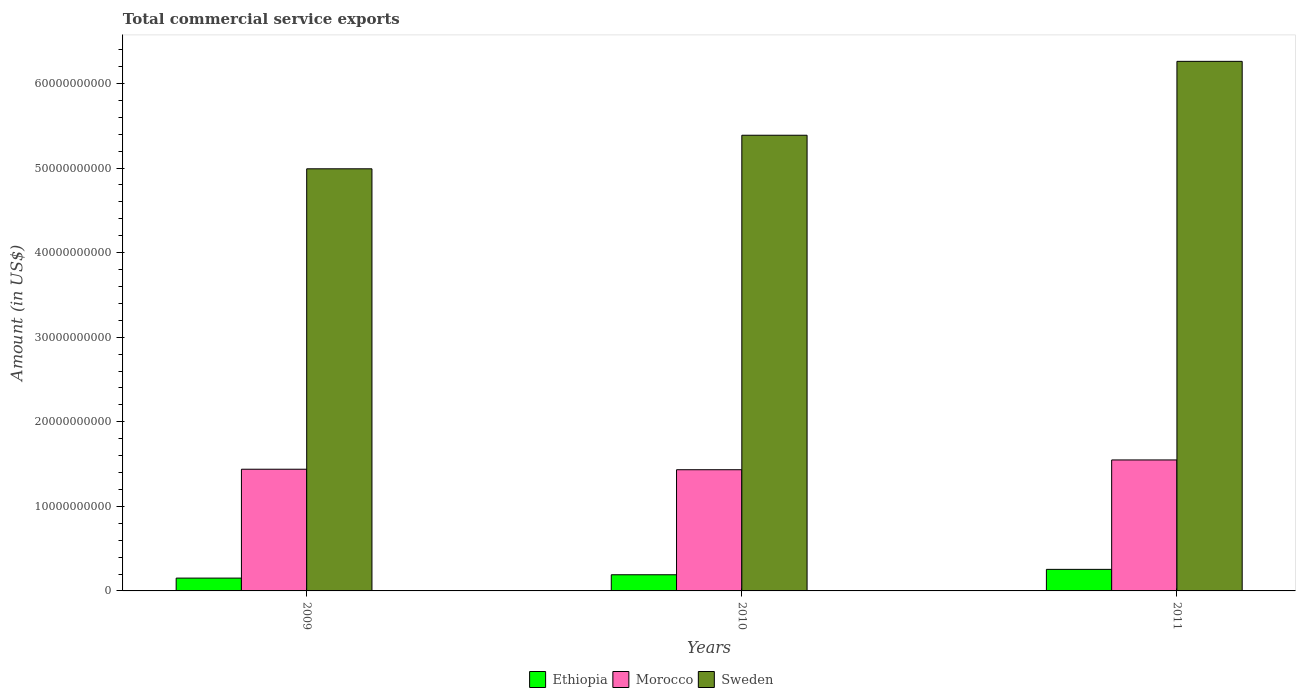How many groups of bars are there?
Ensure brevity in your answer.  3. How many bars are there on the 3rd tick from the right?
Make the answer very short. 3. In how many cases, is the number of bars for a given year not equal to the number of legend labels?
Provide a short and direct response. 0. What is the total commercial service exports in Ethiopia in 2009?
Offer a very short reply. 1.52e+09. Across all years, what is the maximum total commercial service exports in Ethiopia?
Your response must be concise. 2.55e+09. Across all years, what is the minimum total commercial service exports in Morocco?
Your response must be concise. 1.43e+1. What is the total total commercial service exports in Morocco in the graph?
Your answer should be very brief. 4.42e+1. What is the difference between the total commercial service exports in Morocco in 2009 and that in 2010?
Your answer should be very brief. 5.92e+07. What is the difference between the total commercial service exports in Sweden in 2010 and the total commercial service exports in Ethiopia in 2009?
Offer a terse response. 5.24e+1. What is the average total commercial service exports in Sweden per year?
Provide a short and direct response. 5.55e+1. In the year 2010, what is the difference between the total commercial service exports in Sweden and total commercial service exports in Morocco?
Keep it short and to the point. 3.95e+1. What is the ratio of the total commercial service exports in Morocco in 2009 to that in 2011?
Your answer should be very brief. 0.93. Is the total commercial service exports in Ethiopia in 2010 less than that in 2011?
Make the answer very short. Yes. Is the difference between the total commercial service exports in Sweden in 2010 and 2011 greater than the difference between the total commercial service exports in Morocco in 2010 and 2011?
Your response must be concise. No. What is the difference between the highest and the second highest total commercial service exports in Morocco?
Provide a short and direct response. 1.10e+09. What is the difference between the highest and the lowest total commercial service exports in Sweden?
Provide a short and direct response. 1.27e+1. Is the sum of the total commercial service exports in Morocco in 2010 and 2011 greater than the maximum total commercial service exports in Ethiopia across all years?
Provide a short and direct response. Yes. What does the 2nd bar from the left in 2011 represents?
Provide a short and direct response. Morocco. What does the 2nd bar from the right in 2011 represents?
Provide a succinct answer. Morocco. Is it the case that in every year, the sum of the total commercial service exports in Morocco and total commercial service exports in Ethiopia is greater than the total commercial service exports in Sweden?
Keep it short and to the point. No. How many bars are there?
Your answer should be compact. 9. How many years are there in the graph?
Offer a terse response. 3. What is the difference between two consecutive major ticks on the Y-axis?
Your answer should be very brief. 1.00e+1. Are the values on the major ticks of Y-axis written in scientific E-notation?
Your answer should be very brief. No. Where does the legend appear in the graph?
Give a very brief answer. Bottom center. How many legend labels are there?
Your answer should be compact. 3. How are the legend labels stacked?
Your answer should be compact. Horizontal. What is the title of the graph?
Your answer should be compact. Total commercial service exports. What is the label or title of the X-axis?
Make the answer very short. Years. What is the Amount (in US$) of Ethiopia in 2009?
Offer a terse response. 1.52e+09. What is the Amount (in US$) in Morocco in 2009?
Offer a terse response. 1.44e+1. What is the Amount (in US$) in Sweden in 2009?
Make the answer very short. 4.99e+1. What is the Amount (in US$) of Ethiopia in 2010?
Your response must be concise. 1.91e+09. What is the Amount (in US$) in Morocco in 2010?
Offer a terse response. 1.43e+1. What is the Amount (in US$) of Sweden in 2010?
Your answer should be very brief. 5.39e+1. What is the Amount (in US$) in Ethiopia in 2011?
Provide a short and direct response. 2.55e+09. What is the Amount (in US$) in Morocco in 2011?
Provide a short and direct response. 1.55e+1. What is the Amount (in US$) in Sweden in 2011?
Offer a very short reply. 6.26e+1. Across all years, what is the maximum Amount (in US$) in Ethiopia?
Your answer should be compact. 2.55e+09. Across all years, what is the maximum Amount (in US$) in Morocco?
Make the answer very short. 1.55e+1. Across all years, what is the maximum Amount (in US$) of Sweden?
Give a very brief answer. 6.26e+1. Across all years, what is the minimum Amount (in US$) in Ethiopia?
Give a very brief answer. 1.52e+09. Across all years, what is the minimum Amount (in US$) in Morocco?
Offer a very short reply. 1.43e+1. Across all years, what is the minimum Amount (in US$) in Sweden?
Make the answer very short. 4.99e+1. What is the total Amount (in US$) of Ethiopia in the graph?
Your answer should be very brief. 5.98e+09. What is the total Amount (in US$) of Morocco in the graph?
Keep it short and to the point. 4.42e+1. What is the total Amount (in US$) in Sweden in the graph?
Provide a succinct answer. 1.66e+11. What is the difference between the Amount (in US$) in Ethiopia in 2009 and that in 2010?
Provide a short and direct response. -3.95e+08. What is the difference between the Amount (in US$) in Morocco in 2009 and that in 2010?
Your answer should be very brief. 5.92e+07. What is the difference between the Amount (in US$) of Sweden in 2009 and that in 2010?
Keep it short and to the point. -3.97e+09. What is the difference between the Amount (in US$) of Ethiopia in 2009 and that in 2011?
Offer a very short reply. -1.03e+09. What is the difference between the Amount (in US$) in Morocco in 2009 and that in 2011?
Ensure brevity in your answer.  -1.10e+09. What is the difference between the Amount (in US$) in Sweden in 2009 and that in 2011?
Offer a terse response. -1.27e+1. What is the difference between the Amount (in US$) in Ethiopia in 2010 and that in 2011?
Provide a succinct answer. -6.38e+08. What is the difference between the Amount (in US$) of Morocco in 2010 and that in 2011?
Provide a short and direct response. -1.16e+09. What is the difference between the Amount (in US$) in Sweden in 2010 and that in 2011?
Give a very brief answer. -8.74e+09. What is the difference between the Amount (in US$) in Ethiopia in 2009 and the Amount (in US$) in Morocco in 2010?
Give a very brief answer. -1.28e+1. What is the difference between the Amount (in US$) of Ethiopia in 2009 and the Amount (in US$) of Sweden in 2010?
Your response must be concise. -5.24e+1. What is the difference between the Amount (in US$) in Morocco in 2009 and the Amount (in US$) in Sweden in 2010?
Your answer should be compact. -3.95e+1. What is the difference between the Amount (in US$) in Ethiopia in 2009 and the Amount (in US$) in Morocco in 2011?
Offer a terse response. -1.40e+1. What is the difference between the Amount (in US$) in Ethiopia in 2009 and the Amount (in US$) in Sweden in 2011?
Your answer should be compact. -6.11e+1. What is the difference between the Amount (in US$) in Morocco in 2009 and the Amount (in US$) in Sweden in 2011?
Keep it short and to the point. -4.82e+1. What is the difference between the Amount (in US$) in Ethiopia in 2010 and the Amount (in US$) in Morocco in 2011?
Provide a short and direct response. -1.36e+1. What is the difference between the Amount (in US$) in Ethiopia in 2010 and the Amount (in US$) in Sweden in 2011?
Offer a very short reply. -6.07e+1. What is the difference between the Amount (in US$) in Morocco in 2010 and the Amount (in US$) in Sweden in 2011?
Provide a succinct answer. -4.83e+1. What is the average Amount (in US$) of Ethiopia per year?
Your answer should be very brief. 1.99e+09. What is the average Amount (in US$) of Morocco per year?
Keep it short and to the point. 1.47e+1. What is the average Amount (in US$) in Sweden per year?
Ensure brevity in your answer.  5.55e+1. In the year 2009, what is the difference between the Amount (in US$) in Ethiopia and Amount (in US$) in Morocco?
Give a very brief answer. -1.29e+1. In the year 2009, what is the difference between the Amount (in US$) in Ethiopia and Amount (in US$) in Sweden?
Your response must be concise. -4.84e+1. In the year 2009, what is the difference between the Amount (in US$) of Morocco and Amount (in US$) of Sweden?
Your answer should be compact. -3.55e+1. In the year 2010, what is the difference between the Amount (in US$) of Ethiopia and Amount (in US$) of Morocco?
Provide a short and direct response. -1.24e+1. In the year 2010, what is the difference between the Amount (in US$) of Ethiopia and Amount (in US$) of Sweden?
Offer a very short reply. -5.20e+1. In the year 2010, what is the difference between the Amount (in US$) in Morocco and Amount (in US$) in Sweden?
Your answer should be compact. -3.95e+1. In the year 2011, what is the difference between the Amount (in US$) in Ethiopia and Amount (in US$) in Morocco?
Offer a very short reply. -1.29e+1. In the year 2011, what is the difference between the Amount (in US$) in Ethiopia and Amount (in US$) in Sweden?
Your response must be concise. -6.01e+1. In the year 2011, what is the difference between the Amount (in US$) of Morocco and Amount (in US$) of Sweden?
Provide a succinct answer. -4.71e+1. What is the ratio of the Amount (in US$) in Ethiopia in 2009 to that in 2010?
Give a very brief answer. 0.79. What is the ratio of the Amount (in US$) in Morocco in 2009 to that in 2010?
Offer a very short reply. 1. What is the ratio of the Amount (in US$) in Sweden in 2009 to that in 2010?
Keep it short and to the point. 0.93. What is the ratio of the Amount (in US$) of Ethiopia in 2009 to that in 2011?
Offer a very short reply. 0.59. What is the ratio of the Amount (in US$) of Morocco in 2009 to that in 2011?
Your answer should be compact. 0.93. What is the ratio of the Amount (in US$) in Sweden in 2009 to that in 2011?
Provide a short and direct response. 0.8. What is the ratio of the Amount (in US$) in Ethiopia in 2010 to that in 2011?
Keep it short and to the point. 0.75. What is the ratio of the Amount (in US$) in Morocco in 2010 to that in 2011?
Provide a succinct answer. 0.93. What is the ratio of the Amount (in US$) of Sweden in 2010 to that in 2011?
Make the answer very short. 0.86. What is the difference between the highest and the second highest Amount (in US$) in Ethiopia?
Make the answer very short. 6.38e+08. What is the difference between the highest and the second highest Amount (in US$) in Morocco?
Keep it short and to the point. 1.10e+09. What is the difference between the highest and the second highest Amount (in US$) of Sweden?
Keep it short and to the point. 8.74e+09. What is the difference between the highest and the lowest Amount (in US$) of Ethiopia?
Your answer should be compact. 1.03e+09. What is the difference between the highest and the lowest Amount (in US$) of Morocco?
Keep it short and to the point. 1.16e+09. What is the difference between the highest and the lowest Amount (in US$) in Sweden?
Your answer should be compact. 1.27e+1. 